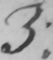What text is written in this handwritten line? 3 . 